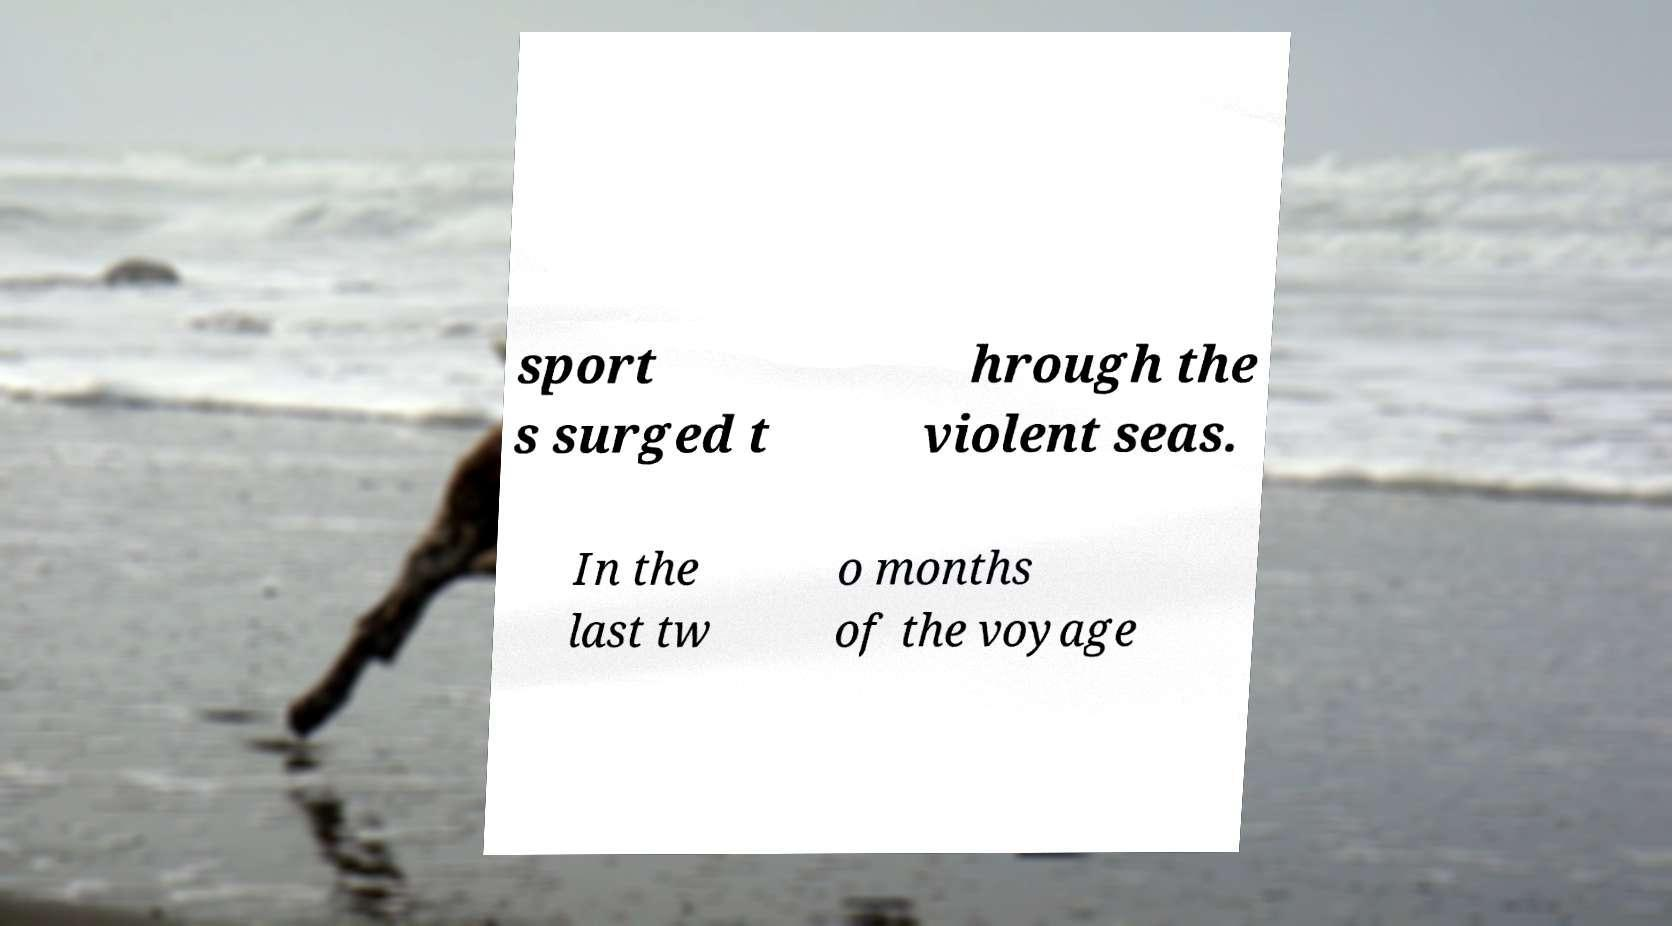Could you assist in decoding the text presented in this image and type it out clearly? sport s surged t hrough the violent seas. In the last tw o months of the voyage 